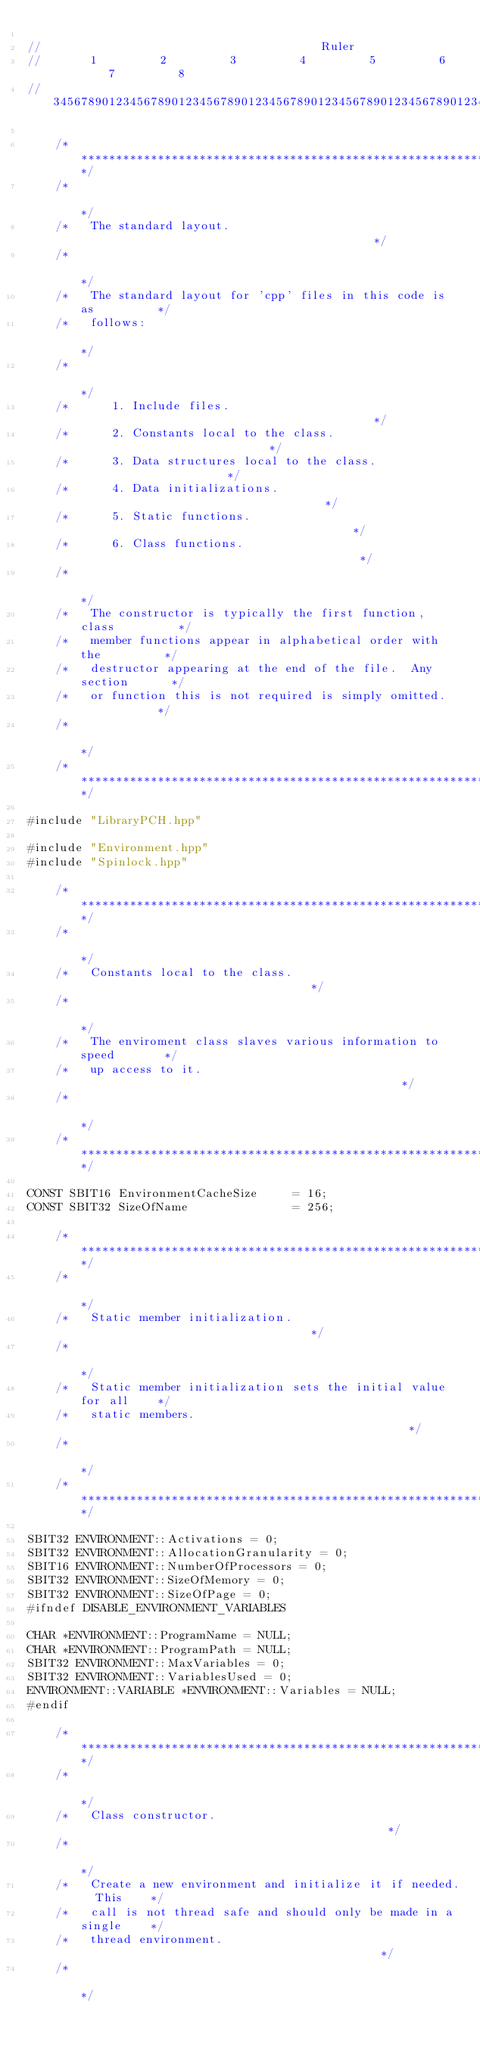Convert code to text. <code><loc_0><loc_0><loc_500><loc_500><_C++_>                          
//                                        Ruler
//       1         2         3         4         5         6         7         8
//345678901234567890123456789012345678901234567890123456789012345678901234567890

    /********************************************************************/
    /*                                                                  */
    /*   The standard layout.                                           */
    /*                                                                  */
    /*   The standard layout for 'cpp' files in this code is as         */
    /*   follows:                                                       */
    /*                                                                  */
    /*      1. Include files.                                           */
    /*      2. Constants local to the class.                            */
    /*      3. Data structures local to the class.                      */
    /*      4. Data initializations.                                    */
    /*      5. Static functions.                                        */
    /*      6. Class functions.                                         */
    /*                                                                  */
    /*   The constructor is typically the first function, class         */
    /*   member functions appear in alphabetical order with the         */
    /*   destructor appearing at the end of the file.  Any section      */
    /*   or function this is not required is simply omitted.            */
    /*                                                                  */
    /********************************************************************/

#include "LibraryPCH.hpp"

#include "Environment.hpp"
#include "Spinlock.hpp"

    /********************************************************************/
    /*                                                                  */
    /*   Constants local to the class.                                  */
    /*                                                                  */
    /*   The enviroment class slaves various information to speed       */
    /*   up access to it.                                               */
    /*                                                                  */
    /********************************************************************/

CONST SBIT16 EnvironmentCacheSize	  = 16;
CONST SBIT32 SizeOfName				  = 256;

    /********************************************************************/
    /*                                                                  */
    /*   Static member initialization.                                  */
    /*                                                                  */
    /*   Static member initialization sets the initial value for all    */
    /*   static members.                                                */
    /*                                                                  */
    /********************************************************************/

SBIT32 ENVIRONMENT::Activations = 0;
SBIT32 ENVIRONMENT::AllocationGranularity = 0;
SBIT16 ENVIRONMENT::NumberOfProcessors = 0;
SBIT32 ENVIRONMENT::SizeOfMemory = 0;
SBIT32 ENVIRONMENT::SizeOfPage = 0;
#ifndef DISABLE_ENVIRONMENT_VARIABLES

CHAR *ENVIRONMENT::ProgramName = NULL;
CHAR *ENVIRONMENT::ProgramPath = NULL;
SBIT32 ENVIRONMENT::MaxVariables = 0;
SBIT32 ENVIRONMENT::VariablesUsed = 0;
ENVIRONMENT::VARIABLE *ENVIRONMENT::Variables = NULL;
#endif

    /********************************************************************/
    /*                                                                  */
    /*   Class constructor.                                             */
    /*                                                                  */
    /*   Create a new environment and initialize it if needed.  This    */
    /*   call is not thread safe and should only be made in a single    */
    /*   thread environment.                                            */
    /*                                                                  */</code> 